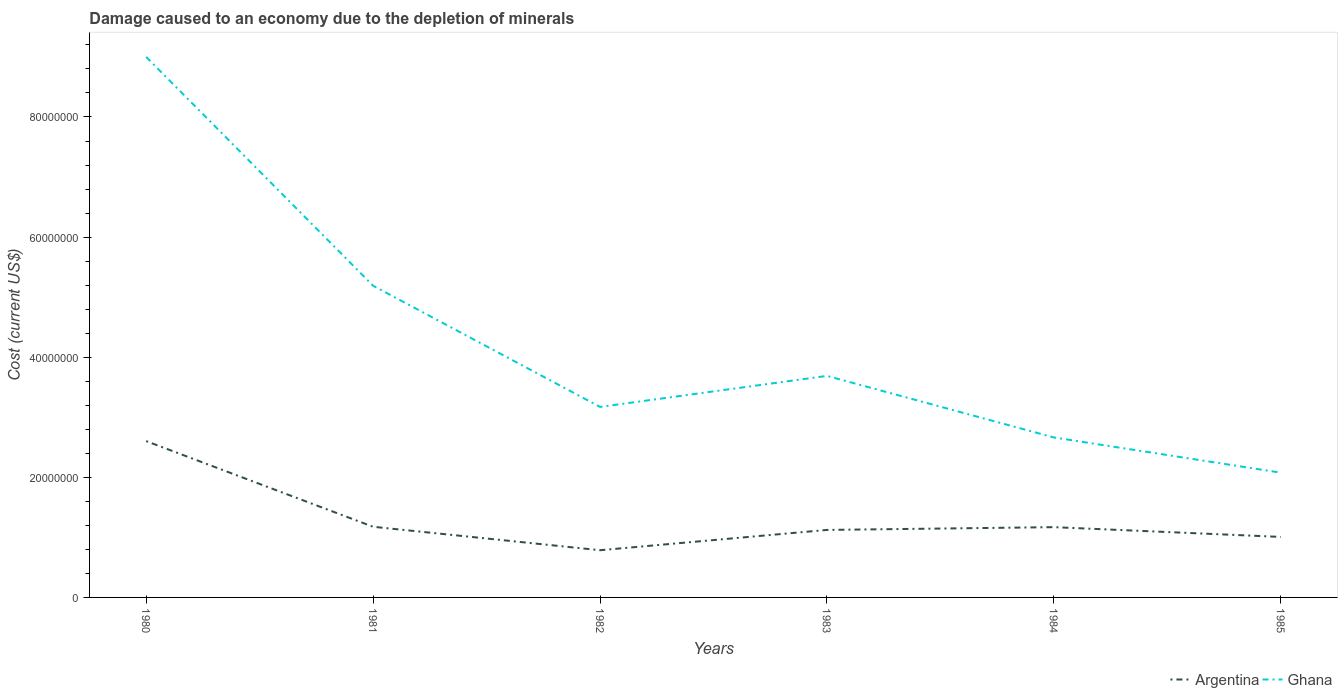How many different coloured lines are there?
Offer a terse response. 2. Does the line corresponding to Ghana intersect with the line corresponding to Argentina?
Provide a succinct answer. No. Is the number of lines equal to the number of legend labels?
Your response must be concise. Yes. Across all years, what is the maximum cost of damage caused due to the depletion of minerals in Argentina?
Provide a short and direct response. 7.86e+06. In which year was the cost of damage caused due to the depletion of minerals in Argentina maximum?
Give a very brief answer. 1982. What is the total cost of damage caused due to the depletion of minerals in Ghana in the graph?
Keep it short and to the point. -5.16e+06. What is the difference between the highest and the second highest cost of damage caused due to the depletion of minerals in Ghana?
Your response must be concise. 6.92e+07. What is the difference between the highest and the lowest cost of damage caused due to the depletion of minerals in Ghana?
Give a very brief answer. 2. How many years are there in the graph?
Your response must be concise. 6. What is the difference between two consecutive major ticks on the Y-axis?
Keep it short and to the point. 2.00e+07. Does the graph contain grids?
Make the answer very short. No. How many legend labels are there?
Provide a short and direct response. 2. What is the title of the graph?
Give a very brief answer. Damage caused to an economy due to the depletion of minerals. Does "Nigeria" appear as one of the legend labels in the graph?
Offer a terse response. No. What is the label or title of the Y-axis?
Provide a succinct answer. Cost (current US$). What is the Cost (current US$) of Argentina in 1980?
Provide a short and direct response. 2.60e+07. What is the Cost (current US$) in Ghana in 1980?
Offer a very short reply. 9.00e+07. What is the Cost (current US$) in Argentina in 1981?
Keep it short and to the point. 1.18e+07. What is the Cost (current US$) of Ghana in 1981?
Your response must be concise. 5.19e+07. What is the Cost (current US$) of Argentina in 1982?
Your answer should be very brief. 7.86e+06. What is the Cost (current US$) of Ghana in 1982?
Your response must be concise. 3.17e+07. What is the Cost (current US$) of Argentina in 1983?
Give a very brief answer. 1.12e+07. What is the Cost (current US$) of Ghana in 1983?
Give a very brief answer. 3.69e+07. What is the Cost (current US$) of Argentina in 1984?
Your response must be concise. 1.17e+07. What is the Cost (current US$) in Ghana in 1984?
Provide a succinct answer. 2.66e+07. What is the Cost (current US$) of Argentina in 1985?
Your answer should be very brief. 1.01e+07. What is the Cost (current US$) in Ghana in 1985?
Provide a succinct answer. 2.08e+07. Across all years, what is the maximum Cost (current US$) of Argentina?
Provide a succinct answer. 2.60e+07. Across all years, what is the maximum Cost (current US$) of Ghana?
Give a very brief answer. 9.00e+07. Across all years, what is the minimum Cost (current US$) in Argentina?
Offer a terse response. 7.86e+06. Across all years, what is the minimum Cost (current US$) in Ghana?
Make the answer very short. 2.08e+07. What is the total Cost (current US$) in Argentina in the graph?
Offer a terse response. 7.87e+07. What is the total Cost (current US$) in Ghana in the graph?
Make the answer very short. 2.58e+08. What is the difference between the Cost (current US$) in Argentina in 1980 and that in 1981?
Your answer should be very brief. 1.43e+07. What is the difference between the Cost (current US$) in Ghana in 1980 and that in 1981?
Offer a terse response. 3.81e+07. What is the difference between the Cost (current US$) of Argentina in 1980 and that in 1982?
Your answer should be very brief. 1.82e+07. What is the difference between the Cost (current US$) in Ghana in 1980 and that in 1982?
Provide a short and direct response. 5.83e+07. What is the difference between the Cost (current US$) of Argentina in 1980 and that in 1983?
Make the answer very short. 1.48e+07. What is the difference between the Cost (current US$) of Ghana in 1980 and that in 1983?
Offer a terse response. 5.31e+07. What is the difference between the Cost (current US$) of Argentina in 1980 and that in 1984?
Provide a succinct answer. 1.43e+07. What is the difference between the Cost (current US$) in Ghana in 1980 and that in 1984?
Provide a succinct answer. 6.34e+07. What is the difference between the Cost (current US$) in Argentina in 1980 and that in 1985?
Provide a succinct answer. 1.60e+07. What is the difference between the Cost (current US$) of Ghana in 1980 and that in 1985?
Make the answer very short. 6.92e+07. What is the difference between the Cost (current US$) of Argentina in 1981 and that in 1982?
Ensure brevity in your answer.  3.91e+06. What is the difference between the Cost (current US$) in Ghana in 1981 and that in 1982?
Your answer should be compact. 2.02e+07. What is the difference between the Cost (current US$) of Argentina in 1981 and that in 1983?
Ensure brevity in your answer.  5.26e+05. What is the difference between the Cost (current US$) of Ghana in 1981 and that in 1983?
Provide a short and direct response. 1.50e+07. What is the difference between the Cost (current US$) in Argentina in 1981 and that in 1984?
Your answer should be compact. 6.34e+04. What is the difference between the Cost (current US$) in Ghana in 1981 and that in 1984?
Provide a succinct answer. 2.53e+07. What is the difference between the Cost (current US$) in Argentina in 1981 and that in 1985?
Your answer should be very brief. 1.69e+06. What is the difference between the Cost (current US$) in Ghana in 1981 and that in 1985?
Your answer should be compact. 3.11e+07. What is the difference between the Cost (current US$) in Argentina in 1982 and that in 1983?
Make the answer very short. -3.38e+06. What is the difference between the Cost (current US$) of Ghana in 1982 and that in 1983?
Your answer should be very brief. -5.16e+06. What is the difference between the Cost (current US$) of Argentina in 1982 and that in 1984?
Make the answer very short. -3.84e+06. What is the difference between the Cost (current US$) in Ghana in 1982 and that in 1984?
Offer a terse response. 5.09e+06. What is the difference between the Cost (current US$) in Argentina in 1982 and that in 1985?
Ensure brevity in your answer.  -2.21e+06. What is the difference between the Cost (current US$) of Ghana in 1982 and that in 1985?
Offer a very short reply. 1.09e+07. What is the difference between the Cost (current US$) of Argentina in 1983 and that in 1984?
Provide a short and direct response. -4.63e+05. What is the difference between the Cost (current US$) of Ghana in 1983 and that in 1984?
Make the answer very short. 1.02e+07. What is the difference between the Cost (current US$) in Argentina in 1983 and that in 1985?
Provide a succinct answer. 1.16e+06. What is the difference between the Cost (current US$) of Ghana in 1983 and that in 1985?
Offer a terse response. 1.61e+07. What is the difference between the Cost (current US$) of Argentina in 1984 and that in 1985?
Keep it short and to the point. 1.63e+06. What is the difference between the Cost (current US$) in Ghana in 1984 and that in 1985?
Provide a succinct answer. 5.86e+06. What is the difference between the Cost (current US$) of Argentina in 1980 and the Cost (current US$) of Ghana in 1981?
Give a very brief answer. -2.59e+07. What is the difference between the Cost (current US$) of Argentina in 1980 and the Cost (current US$) of Ghana in 1982?
Offer a terse response. -5.69e+06. What is the difference between the Cost (current US$) of Argentina in 1980 and the Cost (current US$) of Ghana in 1983?
Offer a terse response. -1.09e+07. What is the difference between the Cost (current US$) in Argentina in 1980 and the Cost (current US$) in Ghana in 1984?
Ensure brevity in your answer.  -6.09e+05. What is the difference between the Cost (current US$) in Argentina in 1980 and the Cost (current US$) in Ghana in 1985?
Your response must be concise. 5.25e+06. What is the difference between the Cost (current US$) of Argentina in 1981 and the Cost (current US$) of Ghana in 1982?
Provide a succinct answer. -2.00e+07. What is the difference between the Cost (current US$) of Argentina in 1981 and the Cost (current US$) of Ghana in 1983?
Your answer should be very brief. -2.51e+07. What is the difference between the Cost (current US$) of Argentina in 1981 and the Cost (current US$) of Ghana in 1984?
Offer a very short reply. -1.49e+07. What is the difference between the Cost (current US$) in Argentina in 1981 and the Cost (current US$) in Ghana in 1985?
Your answer should be compact. -9.01e+06. What is the difference between the Cost (current US$) of Argentina in 1982 and the Cost (current US$) of Ghana in 1983?
Your answer should be compact. -2.90e+07. What is the difference between the Cost (current US$) in Argentina in 1982 and the Cost (current US$) in Ghana in 1984?
Give a very brief answer. -1.88e+07. What is the difference between the Cost (current US$) of Argentina in 1982 and the Cost (current US$) of Ghana in 1985?
Your answer should be very brief. -1.29e+07. What is the difference between the Cost (current US$) of Argentina in 1983 and the Cost (current US$) of Ghana in 1984?
Your response must be concise. -1.54e+07. What is the difference between the Cost (current US$) in Argentina in 1983 and the Cost (current US$) in Ghana in 1985?
Offer a terse response. -9.54e+06. What is the difference between the Cost (current US$) in Argentina in 1984 and the Cost (current US$) in Ghana in 1985?
Your answer should be very brief. -9.07e+06. What is the average Cost (current US$) of Argentina per year?
Your answer should be very brief. 1.31e+07. What is the average Cost (current US$) of Ghana per year?
Ensure brevity in your answer.  4.30e+07. In the year 1980, what is the difference between the Cost (current US$) of Argentina and Cost (current US$) of Ghana?
Give a very brief answer. -6.40e+07. In the year 1981, what is the difference between the Cost (current US$) in Argentina and Cost (current US$) in Ghana?
Ensure brevity in your answer.  -4.01e+07. In the year 1982, what is the difference between the Cost (current US$) of Argentina and Cost (current US$) of Ghana?
Your response must be concise. -2.39e+07. In the year 1983, what is the difference between the Cost (current US$) in Argentina and Cost (current US$) in Ghana?
Your response must be concise. -2.56e+07. In the year 1984, what is the difference between the Cost (current US$) of Argentina and Cost (current US$) of Ghana?
Make the answer very short. -1.49e+07. In the year 1985, what is the difference between the Cost (current US$) in Argentina and Cost (current US$) in Ghana?
Your response must be concise. -1.07e+07. What is the ratio of the Cost (current US$) of Argentina in 1980 to that in 1981?
Give a very brief answer. 2.21. What is the ratio of the Cost (current US$) in Ghana in 1980 to that in 1981?
Ensure brevity in your answer.  1.73. What is the ratio of the Cost (current US$) of Argentina in 1980 to that in 1982?
Keep it short and to the point. 3.31. What is the ratio of the Cost (current US$) in Ghana in 1980 to that in 1982?
Ensure brevity in your answer.  2.84. What is the ratio of the Cost (current US$) in Argentina in 1980 to that in 1983?
Ensure brevity in your answer.  2.32. What is the ratio of the Cost (current US$) of Ghana in 1980 to that in 1983?
Your answer should be compact. 2.44. What is the ratio of the Cost (current US$) of Argentina in 1980 to that in 1984?
Provide a short and direct response. 2.22. What is the ratio of the Cost (current US$) in Ghana in 1980 to that in 1984?
Your answer should be very brief. 3.38. What is the ratio of the Cost (current US$) in Argentina in 1980 to that in 1985?
Keep it short and to the point. 2.58. What is the ratio of the Cost (current US$) of Ghana in 1980 to that in 1985?
Your answer should be very brief. 4.33. What is the ratio of the Cost (current US$) of Argentina in 1981 to that in 1982?
Offer a very short reply. 1.5. What is the ratio of the Cost (current US$) in Ghana in 1981 to that in 1982?
Offer a very short reply. 1.64. What is the ratio of the Cost (current US$) of Argentina in 1981 to that in 1983?
Your answer should be very brief. 1.05. What is the ratio of the Cost (current US$) in Ghana in 1981 to that in 1983?
Your answer should be very brief. 1.41. What is the ratio of the Cost (current US$) in Argentina in 1981 to that in 1984?
Provide a succinct answer. 1.01. What is the ratio of the Cost (current US$) in Ghana in 1981 to that in 1984?
Your response must be concise. 1.95. What is the ratio of the Cost (current US$) in Argentina in 1981 to that in 1985?
Give a very brief answer. 1.17. What is the ratio of the Cost (current US$) of Ghana in 1981 to that in 1985?
Give a very brief answer. 2.5. What is the ratio of the Cost (current US$) in Argentina in 1982 to that in 1983?
Your answer should be compact. 0.7. What is the ratio of the Cost (current US$) in Ghana in 1982 to that in 1983?
Ensure brevity in your answer.  0.86. What is the ratio of the Cost (current US$) in Argentina in 1982 to that in 1984?
Make the answer very short. 0.67. What is the ratio of the Cost (current US$) of Ghana in 1982 to that in 1984?
Your answer should be very brief. 1.19. What is the ratio of the Cost (current US$) in Argentina in 1982 to that in 1985?
Offer a terse response. 0.78. What is the ratio of the Cost (current US$) of Ghana in 1982 to that in 1985?
Your response must be concise. 1.53. What is the ratio of the Cost (current US$) in Argentina in 1983 to that in 1984?
Offer a very short reply. 0.96. What is the ratio of the Cost (current US$) of Ghana in 1983 to that in 1984?
Provide a succinct answer. 1.38. What is the ratio of the Cost (current US$) in Argentina in 1983 to that in 1985?
Ensure brevity in your answer.  1.12. What is the ratio of the Cost (current US$) in Ghana in 1983 to that in 1985?
Your response must be concise. 1.78. What is the ratio of the Cost (current US$) of Argentina in 1984 to that in 1985?
Your answer should be compact. 1.16. What is the ratio of the Cost (current US$) of Ghana in 1984 to that in 1985?
Give a very brief answer. 1.28. What is the difference between the highest and the second highest Cost (current US$) in Argentina?
Provide a succinct answer. 1.43e+07. What is the difference between the highest and the second highest Cost (current US$) of Ghana?
Your response must be concise. 3.81e+07. What is the difference between the highest and the lowest Cost (current US$) in Argentina?
Your answer should be compact. 1.82e+07. What is the difference between the highest and the lowest Cost (current US$) in Ghana?
Give a very brief answer. 6.92e+07. 